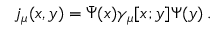<formula> <loc_0><loc_0><loc_500><loc_500>j _ { \mu } ( x , y ) = { \bar { \Psi } } ( x ) \gamma _ { \mu } [ x ; y ] \Psi ( y ) \, .</formula> 